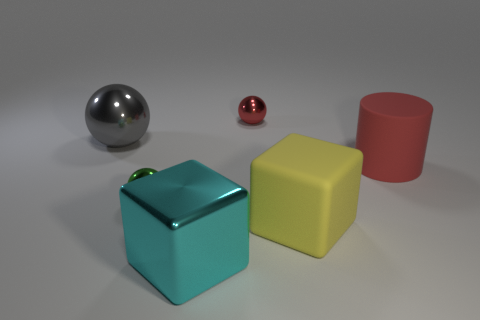Add 2 gray spheres. How many objects exist? 8 Subtract all cylinders. How many objects are left? 5 Subtract 0 gray cylinders. How many objects are left? 6 Subtract all cyan shiny objects. Subtract all cyan spheres. How many objects are left? 5 Add 4 red rubber cylinders. How many red rubber cylinders are left? 5 Add 5 gray spheres. How many gray spheres exist? 6 